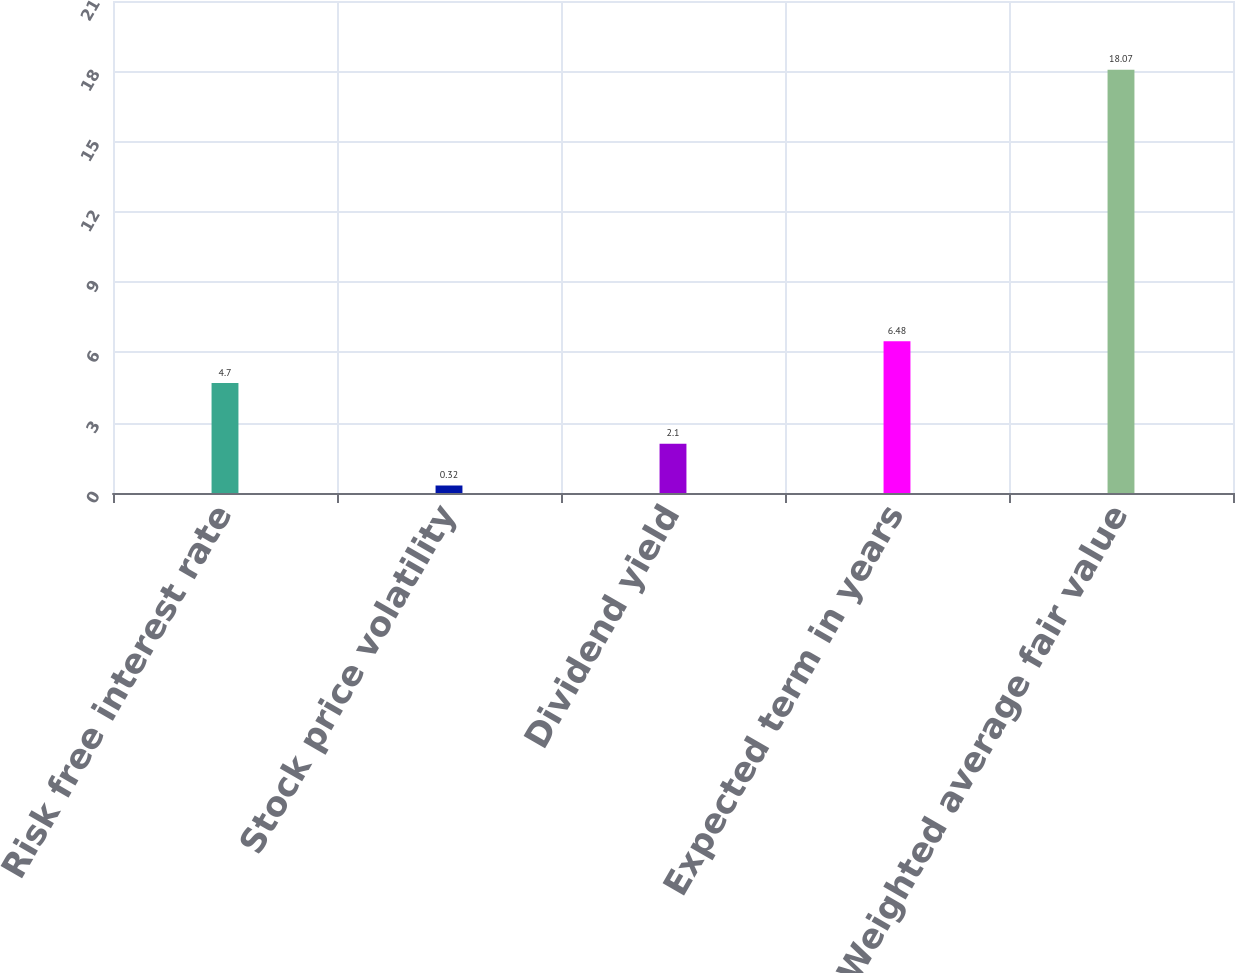Convert chart to OTSL. <chart><loc_0><loc_0><loc_500><loc_500><bar_chart><fcel>Risk free interest rate<fcel>Stock price volatility<fcel>Dividend yield<fcel>Expected term in years<fcel>Weighted average fair value<nl><fcel>4.7<fcel>0.32<fcel>2.1<fcel>6.48<fcel>18.07<nl></chart> 